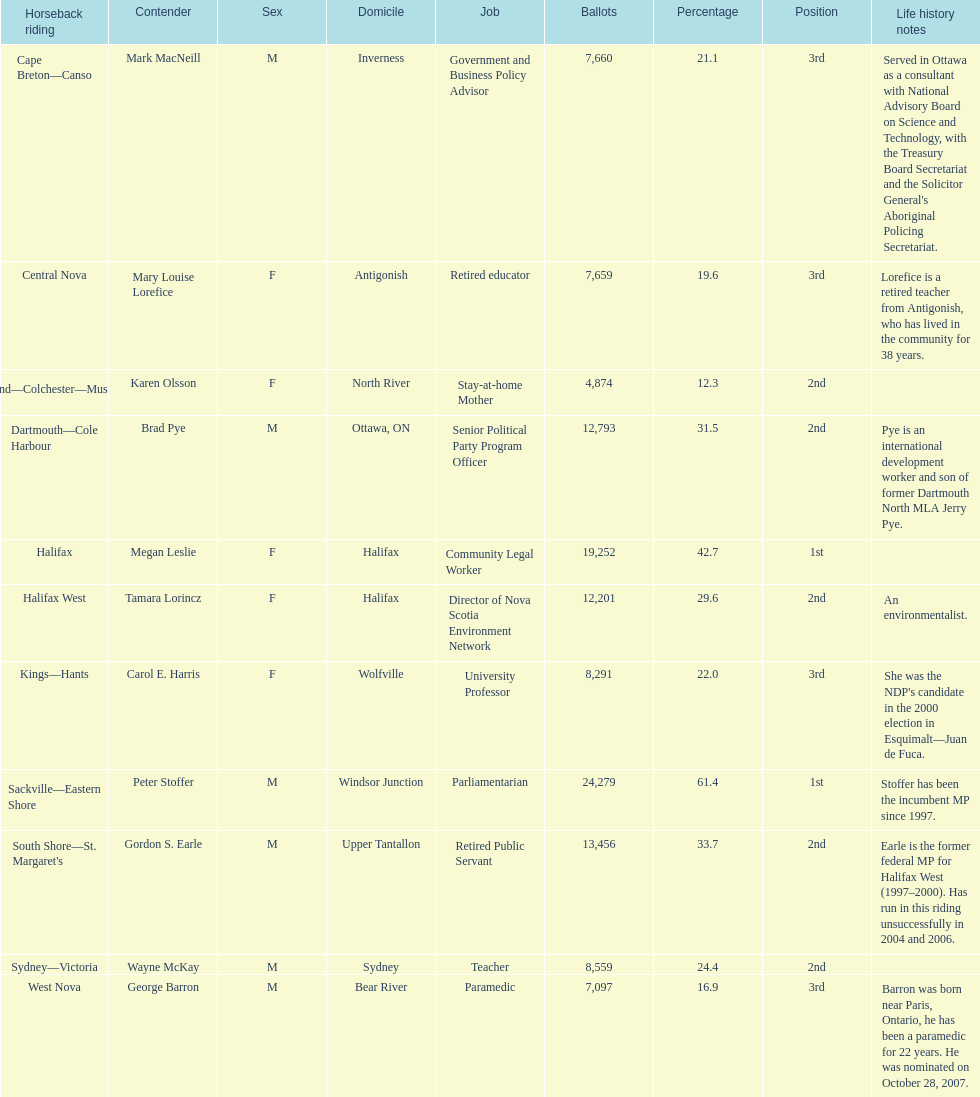How many votes did macneill receive? 7,660. How many votes did olsoon receive? 4,874. Between macneil and olsson, who received more votes? Mark MacNeill. 